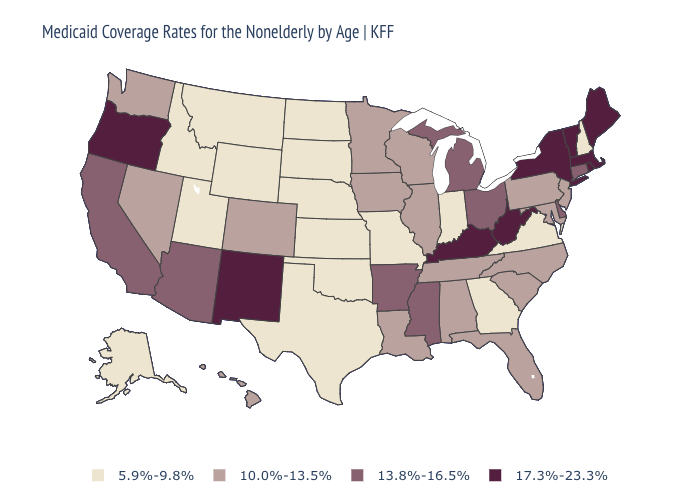What is the value of New Mexico?
Give a very brief answer. 17.3%-23.3%. Which states have the lowest value in the West?
Concise answer only. Alaska, Idaho, Montana, Utah, Wyoming. Name the states that have a value in the range 10.0%-13.5%?
Quick response, please. Alabama, Colorado, Florida, Hawaii, Illinois, Iowa, Louisiana, Maryland, Minnesota, Nevada, New Jersey, North Carolina, Pennsylvania, South Carolina, Tennessee, Washington, Wisconsin. Does Utah have the lowest value in the West?
Concise answer only. Yes. Is the legend a continuous bar?
Keep it brief. No. Among the states that border Texas , which have the highest value?
Answer briefly. New Mexico. Which states have the lowest value in the MidWest?
Be succinct. Indiana, Kansas, Missouri, Nebraska, North Dakota, South Dakota. Name the states that have a value in the range 17.3%-23.3%?
Keep it brief. Kentucky, Maine, Massachusetts, New Mexico, New York, Oregon, Rhode Island, Vermont, West Virginia. What is the highest value in the USA?
Short answer required. 17.3%-23.3%. How many symbols are there in the legend?
Short answer required. 4. Does the map have missing data?
Keep it brief. No. Name the states that have a value in the range 5.9%-9.8%?
Concise answer only. Alaska, Georgia, Idaho, Indiana, Kansas, Missouri, Montana, Nebraska, New Hampshire, North Dakota, Oklahoma, South Dakota, Texas, Utah, Virginia, Wyoming. What is the lowest value in the USA?
Answer briefly. 5.9%-9.8%. Name the states that have a value in the range 5.9%-9.8%?
Be succinct. Alaska, Georgia, Idaho, Indiana, Kansas, Missouri, Montana, Nebraska, New Hampshire, North Dakota, Oklahoma, South Dakota, Texas, Utah, Virginia, Wyoming. What is the value of Washington?
Write a very short answer. 10.0%-13.5%. 